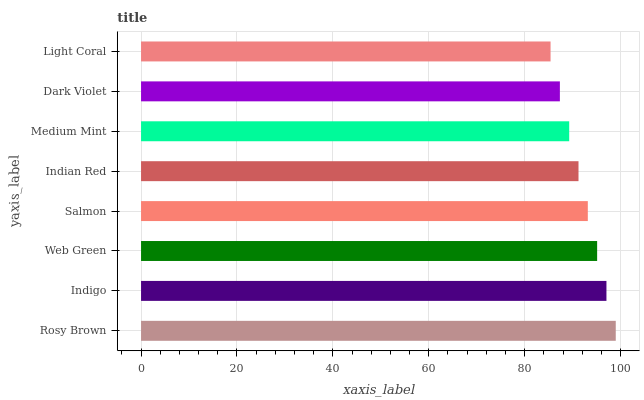Is Light Coral the minimum?
Answer yes or no. Yes. Is Rosy Brown the maximum?
Answer yes or no. Yes. Is Indigo the minimum?
Answer yes or no. No. Is Indigo the maximum?
Answer yes or no. No. Is Rosy Brown greater than Indigo?
Answer yes or no. Yes. Is Indigo less than Rosy Brown?
Answer yes or no. Yes. Is Indigo greater than Rosy Brown?
Answer yes or no. No. Is Rosy Brown less than Indigo?
Answer yes or no. No. Is Salmon the high median?
Answer yes or no. Yes. Is Indian Red the low median?
Answer yes or no. Yes. Is Indian Red the high median?
Answer yes or no. No. Is Indigo the low median?
Answer yes or no. No. 